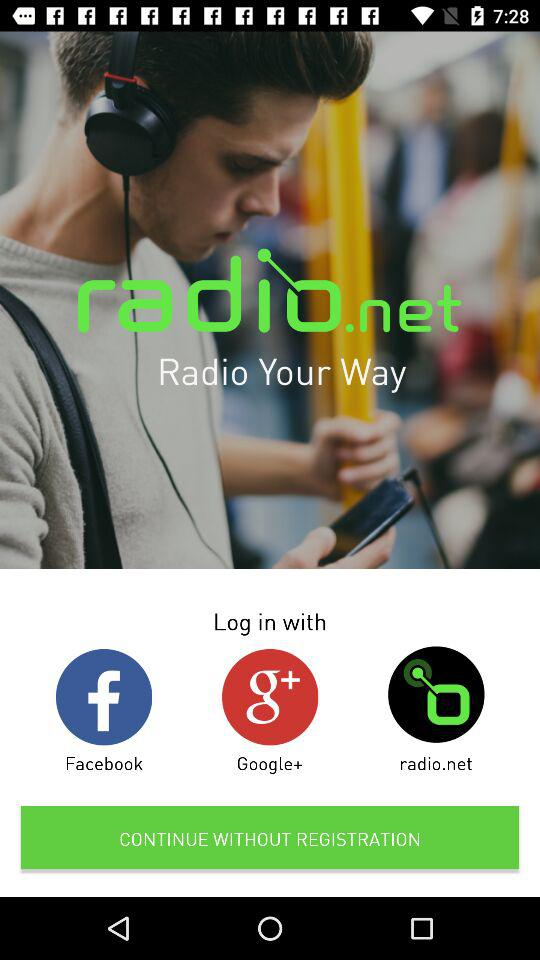How many social login options are there?
Answer the question using a single word or phrase. 3 